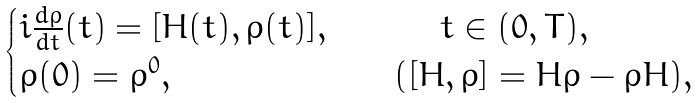Convert formula to latex. <formula><loc_0><loc_0><loc_500><loc_500>\begin{cases} i \frac { d \rho } { d t } ( t ) = [ H ( t ) , \rho ( t ) ] , \quad & \quad \ t \in ( 0 , T ) , \\ \rho ( 0 ) = \rho ^ { 0 } , \quad & ( [ H , \rho ] = H \rho - \rho H ) , \\ \end{cases}</formula> 